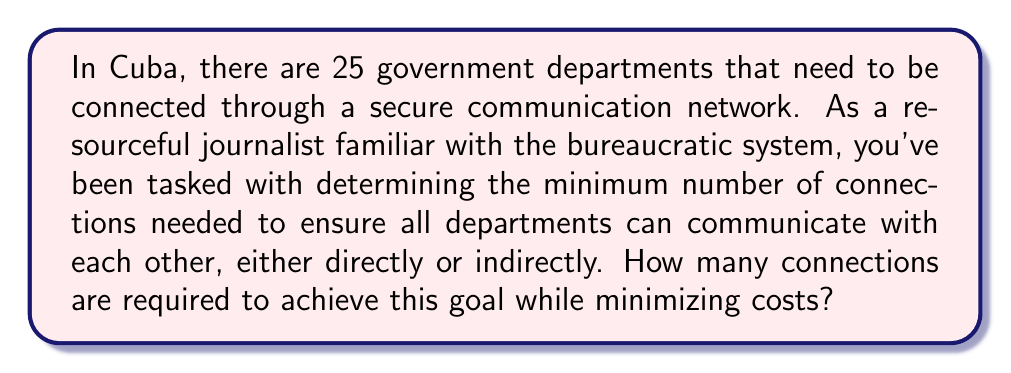Show me your answer to this math problem. This problem can be solved using concepts from graph theory, specifically the minimum spanning tree (MST) of a graph.

1. Model the problem:
   - Each government department is represented as a vertex in a graph.
   - Each connection between departments is an edge in the graph.
   - We need to find the minimum number of edges that connect all vertices.

2. Minimum Spanning Tree:
   - An MST is a subset of edges that connects all vertices with the minimum total edge weight (in this case, the number of edges).
   - For a graph with $n$ vertices, the MST always has exactly $n-1$ edges.

3. Calculate:
   - Number of government departments (vertices): $n = 25$
   - Minimum number of connections (edges) needed: $n - 1 = 25 - 1 = 24$

This solution ensures that:
- All departments are connected (either directly or indirectly).
- The number of connections is minimized, reducing costs.
- There are no cycles in the network, as an MST is by definition acyclic.

[asy]
unitsize(5cm);
int n = 25;
real r = 1;
for (int i = 0; i < n; ++i) {
  pair p = (r*cos(2pi*i/n), r*sin(2pi*i/n));
  dot(p);
  if (i > 0) {
    draw(p -- (r*cos(2pi*(i-1)/n), r*sin(2pi*(i-1)/n)));
  }
}
draw((r,0) -- (r*cos(2pi*24/n), r*sin(2pi*24/n)));
label("Government Departments", (0,-1.2));
[/asy]

The diagram above illustrates a possible arrangement of the 25 departments (dots) and the 24 connections (lines) forming a minimum spanning tree.
Answer: The minimum number of connections needed to link all 25 government departments is 24. 